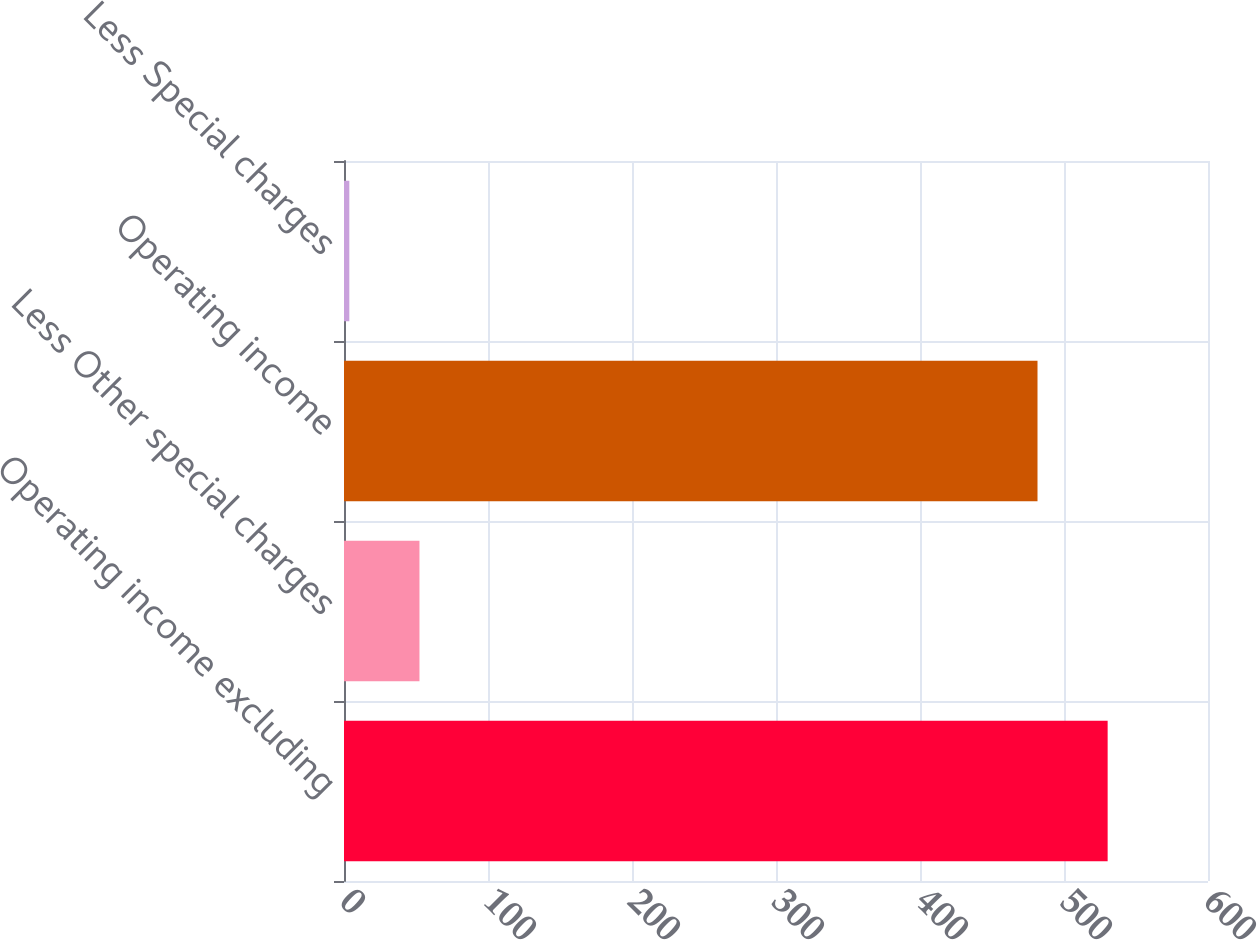<chart> <loc_0><loc_0><loc_500><loc_500><bar_chart><fcel>Operating income excluding<fcel>Less Other special charges<fcel>Operating income<fcel>Less Special charges<nl><fcel>530.31<fcel>52.41<fcel>481.6<fcel>3.7<nl></chart> 